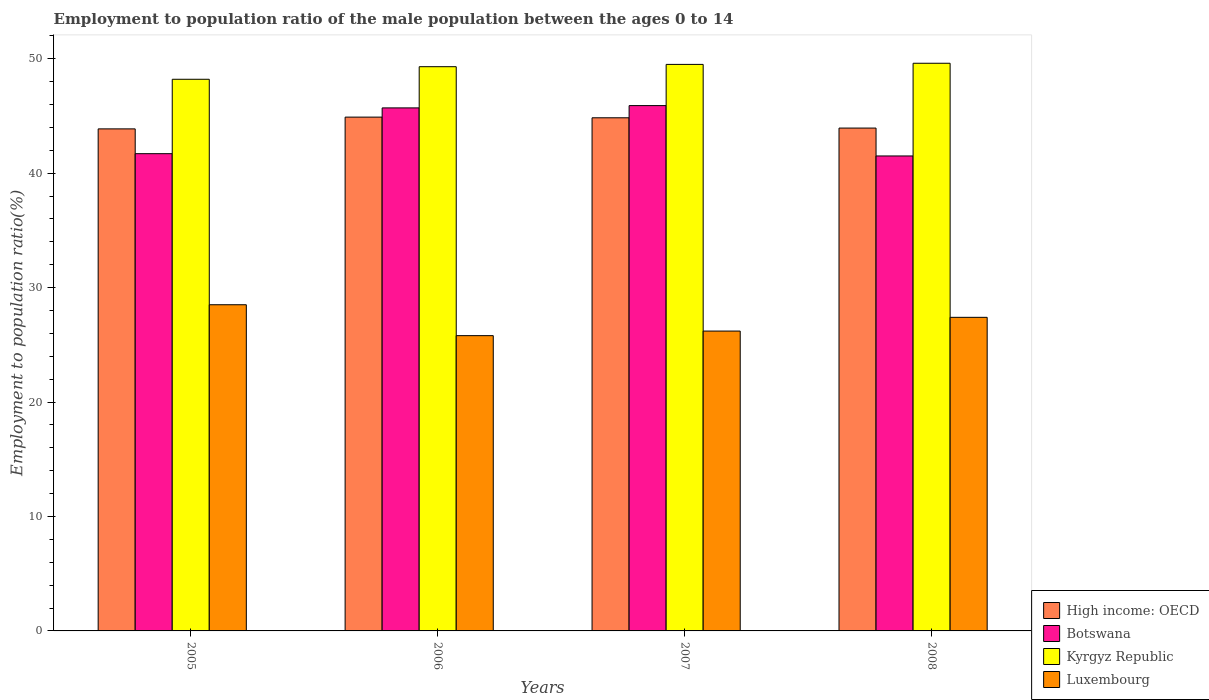Are the number of bars per tick equal to the number of legend labels?
Your response must be concise. Yes. How many bars are there on the 2nd tick from the left?
Offer a terse response. 4. How many bars are there on the 2nd tick from the right?
Ensure brevity in your answer.  4. What is the label of the 3rd group of bars from the left?
Provide a succinct answer. 2007. In how many cases, is the number of bars for a given year not equal to the number of legend labels?
Your answer should be very brief. 0. What is the employment to population ratio in Kyrgyz Republic in 2005?
Make the answer very short. 48.2. Across all years, what is the maximum employment to population ratio in Luxembourg?
Provide a short and direct response. 28.5. Across all years, what is the minimum employment to population ratio in Luxembourg?
Ensure brevity in your answer.  25.8. In which year was the employment to population ratio in Luxembourg maximum?
Provide a succinct answer. 2005. What is the total employment to population ratio in Kyrgyz Republic in the graph?
Offer a very short reply. 196.6. What is the difference between the employment to population ratio in Luxembourg in 2005 and that in 2007?
Your answer should be compact. 2.3. What is the difference between the employment to population ratio in Kyrgyz Republic in 2008 and the employment to population ratio in High income: OECD in 2007?
Provide a short and direct response. 4.76. What is the average employment to population ratio in Luxembourg per year?
Your answer should be compact. 26.97. In the year 2005, what is the difference between the employment to population ratio in Botswana and employment to population ratio in Luxembourg?
Ensure brevity in your answer.  13.2. What is the ratio of the employment to population ratio in Kyrgyz Republic in 2005 to that in 2006?
Your answer should be compact. 0.98. Is the employment to population ratio in Luxembourg in 2007 less than that in 2008?
Make the answer very short. Yes. Is the difference between the employment to population ratio in Botswana in 2005 and 2006 greater than the difference between the employment to population ratio in Luxembourg in 2005 and 2006?
Your answer should be very brief. No. What is the difference between the highest and the second highest employment to population ratio in Kyrgyz Republic?
Provide a succinct answer. 0.1. What is the difference between the highest and the lowest employment to population ratio in Botswana?
Ensure brevity in your answer.  4.4. In how many years, is the employment to population ratio in Luxembourg greater than the average employment to population ratio in Luxembourg taken over all years?
Your answer should be very brief. 2. What does the 2nd bar from the left in 2006 represents?
Make the answer very short. Botswana. What does the 4th bar from the right in 2008 represents?
Offer a very short reply. High income: OECD. How many bars are there?
Make the answer very short. 16. How many years are there in the graph?
Provide a succinct answer. 4. Are the values on the major ticks of Y-axis written in scientific E-notation?
Provide a short and direct response. No. Does the graph contain any zero values?
Provide a succinct answer. No. Where does the legend appear in the graph?
Your answer should be very brief. Bottom right. How many legend labels are there?
Give a very brief answer. 4. What is the title of the graph?
Give a very brief answer. Employment to population ratio of the male population between the ages 0 to 14. What is the label or title of the X-axis?
Your answer should be compact. Years. What is the Employment to population ratio(%) in High income: OECD in 2005?
Offer a very short reply. 43.87. What is the Employment to population ratio(%) in Botswana in 2005?
Provide a succinct answer. 41.7. What is the Employment to population ratio(%) of Kyrgyz Republic in 2005?
Keep it short and to the point. 48.2. What is the Employment to population ratio(%) in Luxembourg in 2005?
Offer a very short reply. 28.5. What is the Employment to population ratio(%) in High income: OECD in 2006?
Offer a very short reply. 44.89. What is the Employment to population ratio(%) in Botswana in 2006?
Ensure brevity in your answer.  45.7. What is the Employment to population ratio(%) in Kyrgyz Republic in 2006?
Make the answer very short. 49.3. What is the Employment to population ratio(%) of Luxembourg in 2006?
Your answer should be compact. 25.8. What is the Employment to population ratio(%) in High income: OECD in 2007?
Make the answer very short. 44.84. What is the Employment to population ratio(%) of Botswana in 2007?
Offer a very short reply. 45.9. What is the Employment to population ratio(%) of Kyrgyz Republic in 2007?
Make the answer very short. 49.5. What is the Employment to population ratio(%) in Luxembourg in 2007?
Give a very brief answer. 26.2. What is the Employment to population ratio(%) of High income: OECD in 2008?
Ensure brevity in your answer.  43.94. What is the Employment to population ratio(%) in Botswana in 2008?
Provide a short and direct response. 41.5. What is the Employment to population ratio(%) of Kyrgyz Republic in 2008?
Offer a very short reply. 49.6. What is the Employment to population ratio(%) in Luxembourg in 2008?
Give a very brief answer. 27.4. Across all years, what is the maximum Employment to population ratio(%) in High income: OECD?
Keep it short and to the point. 44.89. Across all years, what is the maximum Employment to population ratio(%) in Botswana?
Offer a terse response. 45.9. Across all years, what is the maximum Employment to population ratio(%) in Kyrgyz Republic?
Your answer should be compact. 49.6. Across all years, what is the minimum Employment to population ratio(%) in High income: OECD?
Keep it short and to the point. 43.87. Across all years, what is the minimum Employment to population ratio(%) of Botswana?
Make the answer very short. 41.5. Across all years, what is the minimum Employment to population ratio(%) in Kyrgyz Republic?
Offer a very short reply. 48.2. Across all years, what is the minimum Employment to population ratio(%) in Luxembourg?
Offer a terse response. 25.8. What is the total Employment to population ratio(%) in High income: OECD in the graph?
Make the answer very short. 177.53. What is the total Employment to population ratio(%) of Botswana in the graph?
Provide a short and direct response. 174.8. What is the total Employment to population ratio(%) of Kyrgyz Republic in the graph?
Make the answer very short. 196.6. What is the total Employment to population ratio(%) in Luxembourg in the graph?
Provide a short and direct response. 107.9. What is the difference between the Employment to population ratio(%) of High income: OECD in 2005 and that in 2006?
Ensure brevity in your answer.  -1.03. What is the difference between the Employment to population ratio(%) of Kyrgyz Republic in 2005 and that in 2006?
Your answer should be very brief. -1.1. What is the difference between the Employment to population ratio(%) in High income: OECD in 2005 and that in 2007?
Make the answer very short. -0.97. What is the difference between the Employment to population ratio(%) in Botswana in 2005 and that in 2007?
Keep it short and to the point. -4.2. What is the difference between the Employment to population ratio(%) in Luxembourg in 2005 and that in 2007?
Your answer should be compact. 2.3. What is the difference between the Employment to population ratio(%) of High income: OECD in 2005 and that in 2008?
Your response must be concise. -0.07. What is the difference between the Employment to population ratio(%) in Kyrgyz Republic in 2005 and that in 2008?
Your answer should be very brief. -1.4. What is the difference between the Employment to population ratio(%) of High income: OECD in 2006 and that in 2007?
Give a very brief answer. 0.06. What is the difference between the Employment to population ratio(%) of Kyrgyz Republic in 2006 and that in 2007?
Provide a succinct answer. -0.2. What is the difference between the Employment to population ratio(%) in High income: OECD in 2006 and that in 2008?
Give a very brief answer. 0.96. What is the difference between the Employment to population ratio(%) in Botswana in 2006 and that in 2008?
Make the answer very short. 4.2. What is the difference between the Employment to population ratio(%) in Kyrgyz Republic in 2006 and that in 2008?
Make the answer very short. -0.3. What is the difference between the Employment to population ratio(%) in High income: OECD in 2007 and that in 2008?
Provide a short and direct response. 0.9. What is the difference between the Employment to population ratio(%) of Luxembourg in 2007 and that in 2008?
Your answer should be compact. -1.2. What is the difference between the Employment to population ratio(%) of High income: OECD in 2005 and the Employment to population ratio(%) of Botswana in 2006?
Offer a terse response. -1.83. What is the difference between the Employment to population ratio(%) in High income: OECD in 2005 and the Employment to population ratio(%) in Kyrgyz Republic in 2006?
Make the answer very short. -5.43. What is the difference between the Employment to population ratio(%) of High income: OECD in 2005 and the Employment to population ratio(%) of Luxembourg in 2006?
Provide a succinct answer. 18.07. What is the difference between the Employment to population ratio(%) of Botswana in 2005 and the Employment to population ratio(%) of Kyrgyz Republic in 2006?
Give a very brief answer. -7.6. What is the difference between the Employment to population ratio(%) of Botswana in 2005 and the Employment to population ratio(%) of Luxembourg in 2006?
Your response must be concise. 15.9. What is the difference between the Employment to population ratio(%) in Kyrgyz Republic in 2005 and the Employment to population ratio(%) in Luxembourg in 2006?
Your answer should be compact. 22.4. What is the difference between the Employment to population ratio(%) in High income: OECD in 2005 and the Employment to population ratio(%) in Botswana in 2007?
Offer a terse response. -2.03. What is the difference between the Employment to population ratio(%) in High income: OECD in 2005 and the Employment to population ratio(%) in Kyrgyz Republic in 2007?
Give a very brief answer. -5.63. What is the difference between the Employment to population ratio(%) in High income: OECD in 2005 and the Employment to population ratio(%) in Luxembourg in 2007?
Ensure brevity in your answer.  17.67. What is the difference between the Employment to population ratio(%) of Botswana in 2005 and the Employment to population ratio(%) of Kyrgyz Republic in 2007?
Keep it short and to the point. -7.8. What is the difference between the Employment to population ratio(%) of Botswana in 2005 and the Employment to population ratio(%) of Luxembourg in 2007?
Offer a very short reply. 15.5. What is the difference between the Employment to population ratio(%) in Kyrgyz Republic in 2005 and the Employment to population ratio(%) in Luxembourg in 2007?
Your answer should be compact. 22. What is the difference between the Employment to population ratio(%) of High income: OECD in 2005 and the Employment to population ratio(%) of Botswana in 2008?
Your answer should be compact. 2.37. What is the difference between the Employment to population ratio(%) in High income: OECD in 2005 and the Employment to population ratio(%) in Kyrgyz Republic in 2008?
Make the answer very short. -5.73. What is the difference between the Employment to population ratio(%) of High income: OECD in 2005 and the Employment to population ratio(%) of Luxembourg in 2008?
Provide a short and direct response. 16.47. What is the difference between the Employment to population ratio(%) of Botswana in 2005 and the Employment to population ratio(%) of Kyrgyz Republic in 2008?
Ensure brevity in your answer.  -7.9. What is the difference between the Employment to population ratio(%) of Botswana in 2005 and the Employment to population ratio(%) of Luxembourg in 2008?
Your response must be concise. 14.3. What is the difference between the Employment to population ratio(%) in Kyrgyz Republic in 2005 and the Employment to population ratio(%) in Luxembourg in 2008?
Offer a very short reply. 20.8. What is the difference between the Employment to population ratio(%) in High income: OECD in 2006 and the Employment to population ratio(%) in Botswana in 2007?
Offer a very short reply. -1.01. What is the difference between the Employment to population ratio(%) in High income: OECD in 2006 and the Employment to population ratio(%) in Kyrgyz Republic in 2007?
Your answer should be very brief. -4.61. What is the difference between the Employment to population ratio(%) in High income: OECD in 2006 and the Employment to population ratio(%) in Luxembourg in 2007?
Make the answer very short. 18.69. What is the difference between the Employment to population ratio(%) of Kyrgyz Republic in 2006 and the Employment to population ratio(%) of Luxembourg in 2007?
Make the answer very short. 23.1. What is the difference between the Employment to population ratio(%) in High income: OECD in 2006 and the Employment to population ratio(%) in Botswana in 2008?
Your answer should be very brief. 3.39. What is the difference between the Employment to population ratio(%) in High income: OECD in 2006 and the Employment to population ratio(%) in Kyrgyz Republic in 2008?
Keep it short and to the point. -4.71. What is the difference between the Employment to population ratio(%) in High income: OECD in 2006 and the Employment to population ratio(%) in Luxembourg in 2008?
Your answer should be very brief. 17.49. What is the difference between the Employment to population ratio(%) of Kyrgyz Republic in 2006 and the Employment to population ratio(%) of Luxembourg in 2008?
Your answer should be compact. 21.9. What is the difference between the Employment to population ratio(%) in High income: OECD in 2007 and the Employment to population ratio(%) in Botswana in 2008?
Offer a terse response. 3.34. What is the difference between the Employment to population ratio(%) in High income: OECD in 2007 and the Employment to population ratio(%) in Kyrgyz Republic in 2008?
Provide a short and direct response. -4.76. What is the difference between the Employment to population ratio(%) of High income: OECD in 2007 and the Employment to population ratio(%) of Luxembourg in 2008?
Provide a succinct answer. 17.44. What is the difference between the Employment to population ratio(%) of Botswana in 2007 and the Employment to population ratio(%) of Kyrgyz Republic in 2008?
Give a very brief answer. -3.7. What is the difference between the Employment to population ratio(%) of Botswana in 2007 and the Employment to population ratio(%) of Luxembourg in 2008?
Give a very brief answer. 18.5. What is the difference between the Employment to population ratio(%) of Kyrgyz Republic in 2007 and the Employment to population ratio(%) of Luxembourg in 2008?
Make the answer very short. 22.1. What is the average Employment to population ratio(%) in High income: OECD per year?
Offer a terse response. 44.38. What is the average Employment to population ratio(%) of Botswana per year?
Provide a succinct answer. 43.7. What is the average Employment to population ratio(%) in Kyrgyz Republic per year?
Offer a very short reply. 49.15. What is the average Employment to population ratio(%) in Luxembourg per year?
Keep it short and to the point. 26.98. In the year 2005, what is the difference between the Employment to population ratio(%) of High income: OECD and Employment to population ratio(%) of Botswana?
Give a very brief answer. 2.17. In the year 2005, what is the difference between the Employment to population ratio(%) of High income: OECD and Employment to population ratio(%) of Kyrgyz Republic?
Provide a succinct answer. -4.33. In the year 2005, what is the difference between the Employment to population ratio(%) of High income: OECD and Employment to population ratio(%) of Luxembourg?
Your response must be concise. 15.37. In the year 2005, what is the difference between the Employment to population ratio(%) in Botswana and Employment to population ratio(%) in Kyrgyz Republic?
Make the answer very short. -6.5. In the year 2005, what is the difference between the Employment to population ratio(%) of Botswana and Employment to population ratio(%) of Luxembourg?
Make the answer very short. 13.2. In the year 2005, what is the difference between the Employment to population ratio(%) of Kyrgyz Republic and Employment to population ratio(%) of Luxembourg?
Offer a very short reply. 19.7. In the year 2006, what is the difference between the Employment to population ratio(%) of High income: OECD and Employment to population ratio(%) of Botswana?
Your response must be concise. -0.81. In the year 2006, what is the difference between the Employment to population ratio(%) in High income: OECD and Employment to population ratio(%) in Kyrgyz Republic?
Provide a short and direct response. -4.41. In the year 2006, what is the difference between the Employment to population ratio(%) in High income: OECD and Employment to population ratio(%) in Luxembourg?
Offer a terse response. 19.09. In the year 2006, what is the difference between the Employment to population ratio(%) in Botswana and Employment to population ratio(%) in Kyrgyz Republic?
Ensure brevity in your answer.  -3.6. In the year 2006, what is the difference between the Employment to population ratio(%) in Kyrgyz Republic and Employment to population ratio(%) in Luxembourg?
Offer a terse response. 23.5. In the year 2007, what is the difference between the Employment to population ratio(%) of High income: OECD and Employment to population ratio(%) of Botswana?
Offer a very short reply. -1.06. In the year 2007, what is the difference between the Employment to population ratio(%) in High income: OECD and Employment to population ratio(%) in Kyrgyz Republic?
Provide a succinct answer. -4.66. In the year 2007, what is the difference between the Employment to population ratio(%) in High income: OECD and Employment to population ratio(%) in Luxembourg?
Your response must be concise. 18.64. In the year 2007, what is the difference between the Employment to population ratio(%) of Botswana and Employment to population ratio(%) of Kyrgyz Republic?
Your answer should be compact. -3.6. In the year 2007, what is the difference between the Employment to population ratio(%) in Botswana and Employment to population ratio(%) in Luxembourg?
Ensure brevity in your answer.  19.7. In the year 2007, what is the difference between the Employment to population ratio(%) of Kyrgyz Republic and Employment to population ratio(%) of Luxembourg?
Provide a succinct answer. 23.3. In the year 2008, what is the difference between the Employment to population ratio(%) in High income: OECD and Employment to population ratio(%) in Botswana?
Provide a short and direct response. 2.44. In the year 2008, what is the difference between the Employment to population ratio(%) of High income: OECD and Employment to population ratio(%) of Kyrgyz Republic?
Provide a succinct answer. -5.66. In the year 2008, what is the difference between the Employment to population ratio(%) of High income: OECD and Employment to population ratio(%) of Luxembourg?
Provide a succinct answer. 16.54. In the year 2008, what is the difference between the Employment to population ratio(%) of Botswana and Employment to population ratio(%) of Luxembourg?
Make the answer very short. 14.1. What is the ratio of the Employment to population ratio(%) in High income: OECD in 2005 to that in 2006?
Make the answer very short. 0.98. What is the ratio of the Employment to population ratio(%) of Botswana in 2005 to that in 2006?
Give a very brief answer. 0.91. What is the ratio of the Employment to population ratio(%) of Kyrgyz Republic in 2005 to that in 2006?
Keep it short and to the point. 0.98. What is the ratio of the Employment to population ratio(%) of Luxembourg in 2005 to that in 2006?
Make the answer very short. 1.1. What is the ratio of the Employment to population ratio(%) of High income: OECD in 2005 to that in 2007?
Provide a short and direct response. 0.98. What is the ratio of the Employment to population ratio(%) of Botswana in 2005 to that in 2007?
Your response must be concise. 0.91. What is the ratio of the Employment to population ratio(%) of Kyrgyz Republic in 2005 to that in 2007?
Your answer should be compact. 0.97. What is the ratio of the Employment to population ratio(%) of Luxembourg in 2005 to that in 2007?
Your answer should be compact. 1.09. What is the ratio of the Employment to population ratio(%) of Botswana in 2005 to that in 2008?
Your answer should be very brief. 1. What is the ratio of the Employment to population ratio(%) of Kyrgyz Republic in 2005 to that in 2008?
Provide a short and direct response. 0.97. What is the ratio of the Employment to population ratio(%) of Luxembourg in 2005 to that in 2008?
Offer a terse response. 1.04. What is the ratio of the Employment to population ratio(%) of Botswana in 2006 to that in 2007?
Your response must be concise. 1. What is the ratio of the Employment to population ratio(%) in Luxembourg in 2006 to that in 2007?
Provide a short and direct response. 0.98. What is the ratio of the Employment to population ratio(%) in High income: OECD in 2006 to that in 2008?
Your response must be concise. 1.02. What is the ratio of the Employment to population ratio(%) of Botswana in 2006 to that in 2008?
Your response must be concise. 1.1. What is the ratio of the Employment to population ratio(%) in Luxembourg in 2006 to that in 2008?
Provide a short and direct response. 0.94. What is the ratio of the Employment to population ratio(%) in High income: OECD in 2007 to that in 2008?
Ensure brevity in your answer.  1.02. What is the ratio of the Employment to population ratio(%) in Botswana in 2007 to that in 2008?
Provide a short and direct response. 1.11. What is the ratio of the Employment to population ratio(%) of Kyrgyz Republic in 2007 to that in 2008?
Provide a succinct answer. 1. What is the ratio of the Employment to population ratio(%) of Luxembourg in 2007 to that in 2008?
Your answer should be compact. 0.96. What is the difference between the highest and the second highest Employment to population ratio(%) of High income: OECD?
Keep it short and to the point. 0.06. What is the difference between the highest and the second highest Employment to population ratio(%) of Luxembourg?
Offer a very short reply. 1.1. What is the difference between the highest and the lowest Employment to population ratio(%) of High income: OECD?
Offer a very short reply. 1.03. What is the difference between the highest and the lowest Employment to population ratio(%) in Kyrgyz Republic?
Give a very brief answer. 1.4. 